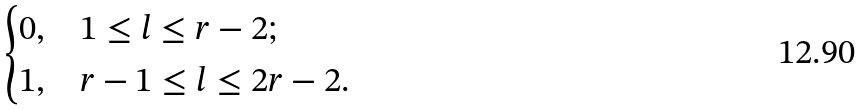<formula> <loc_0><loc_0><loc_500><loc_500>\begin{cases} 0 , & 1 \leq l \leq r - 2 ; \\ 1 , & r - 1 \leq l \leq 2 r - 2 . \end{cases}</formula> 